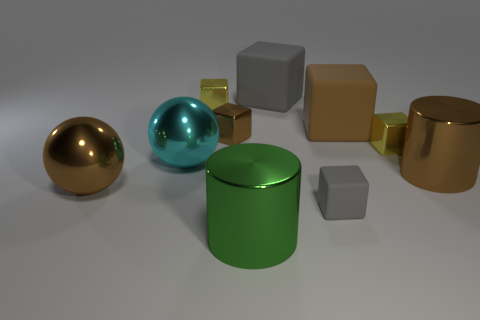Is the brown matte object the same shape as the small brown object?
Your response must be concise. Yes. There is a metallic cube that is on the left side of the small brown block; does it have the same color as the shiny block on the right side of the green object?
Your response must be concise. Yes. Is the number of brown cylinders that are right of the brown metal cylinder less than the number of small yellow shiny blocks that are on the left side of the large green object?
Make the answer very short. Yes. What shape is the small metal thing to the right of the large brown block?
Provide a short and direct response. Cube. There is a large block that is the same color as the small matte thing; what is its material?
Offer a terse response. Rubber. How many other things are made of the same material as the large brown block?
Keep it short and to the point. 2. Does the tiny gray matte object have the same shape as the brown metal thing that is right of the large green metal cylinder?
Offer a very short reply. No. What is the shape of the large cyan object that is made of the same material as the large green cylinder?
Offer a very short reply. Sphere. Are there more big spheres that are to the right of the large brown sphere than big cyan metallic things behind the large brown cube?
Ensure brevity in your answer.  Yes. How many objects are either big green shiny balls or rubber objects?
Keep it short and to the point. 3. 